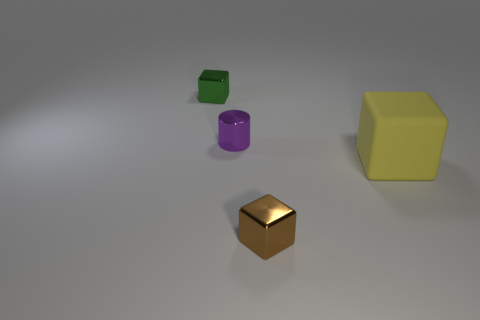Add 3 large gray spheres. How many objects exist? 7 Subtract all cylinders. How many objects are left? 3 Subtract 0 cyan cubes. How many objects are left? 4 Subtract all tiny purple matte cylinders. Subtract all green shiny objects. How many objects are left? 3 Add 2 brown things. How many brown things are left? 3 Add 4 metal cylinders. How many metal cylinders exist? 5 